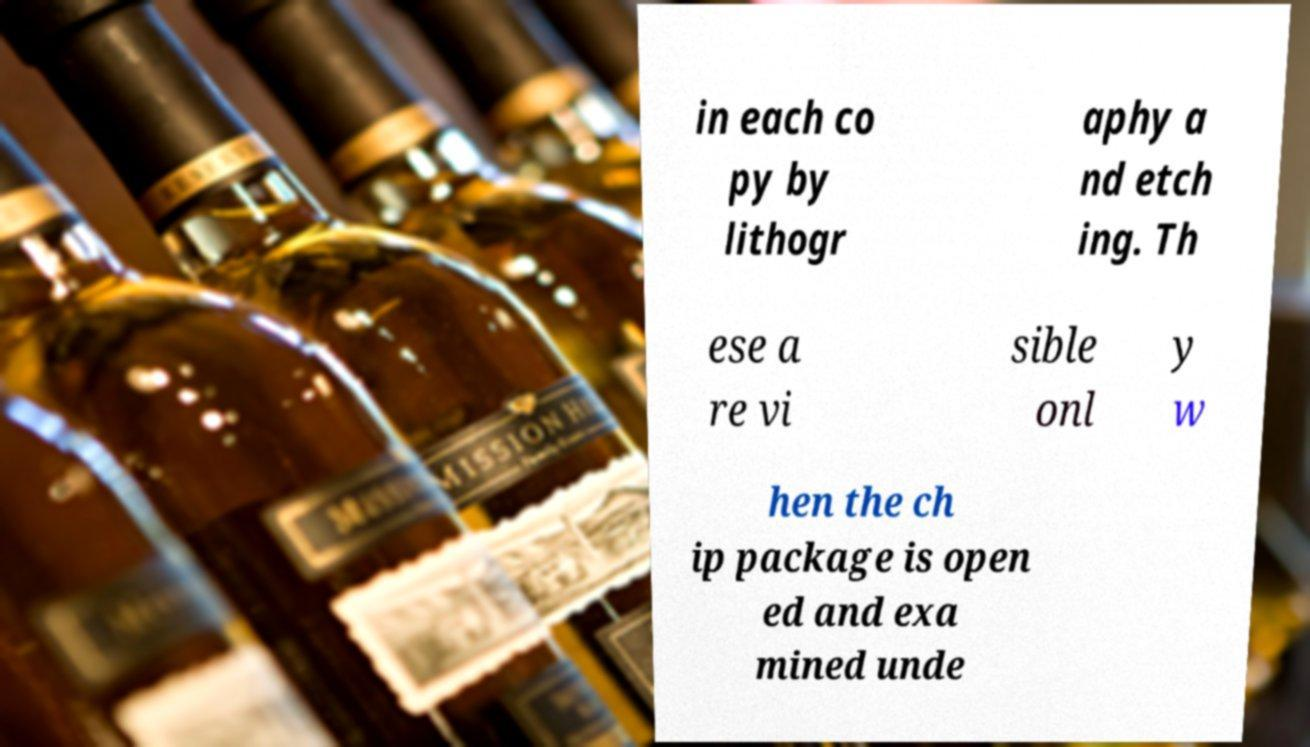Please read and relay the text visible in this image. What does it say? in each co py by lithogr aphy a nd etch ing. Th ese a re vi sible onl y w hen the ch ip package is open ed and exa mined unde 